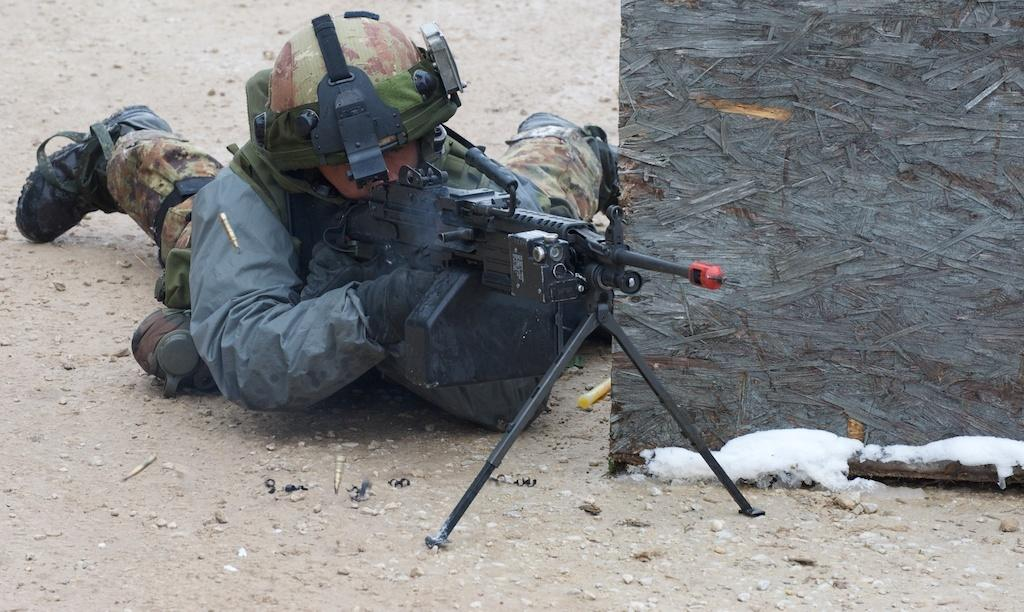What is the person in the image doing? The person is laying down in the image. What type of clothing is the person wearing? The person is wearing a military dress. What object is the person holding? The person is holding a gun. What is the color of the gun? The gun is black in color. What type of cheese is visible in the person's hands in the image? There is no cheese present in the image, and the person's hands are not visible. 